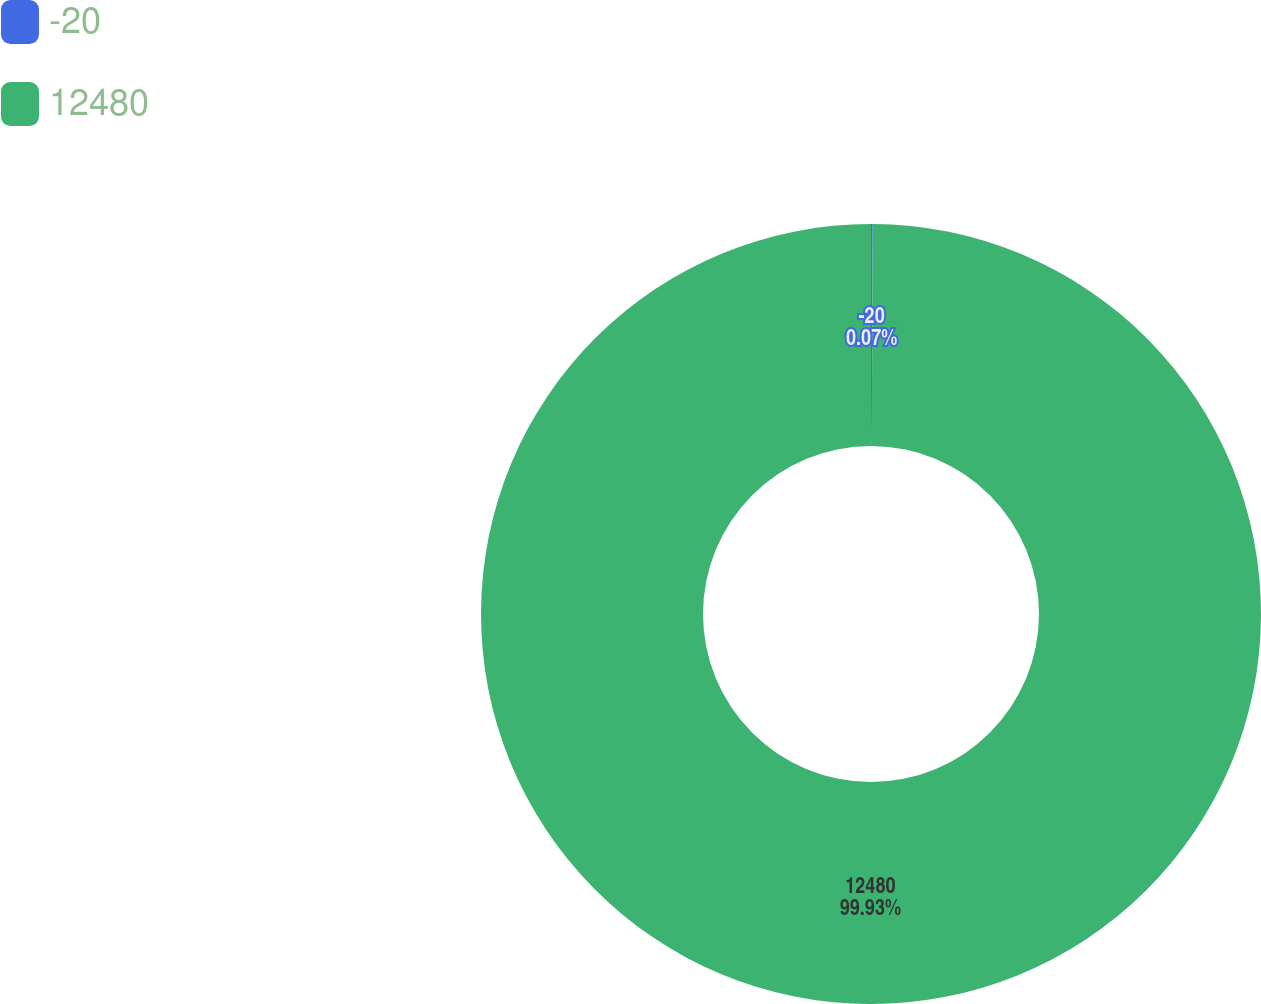Convert chart to OTSL. <chart><loc_0><loc_0><loc_500><loc_500><pie_chart><fcel>-20<fcel>12480<nl><fcel>0.07%<fcel>99.93%<nl></chart> 